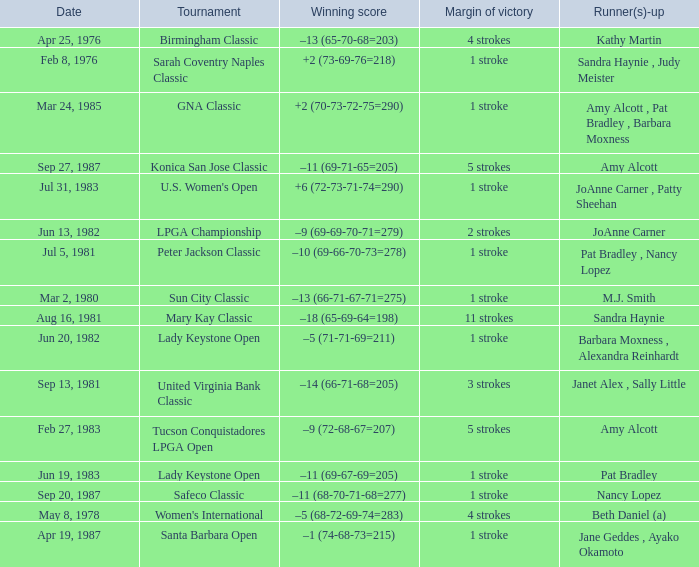What is the margin of victory when the runner-up is amy alcott and the winning score is –9 (72-68-67=207)? 5 strokes. 